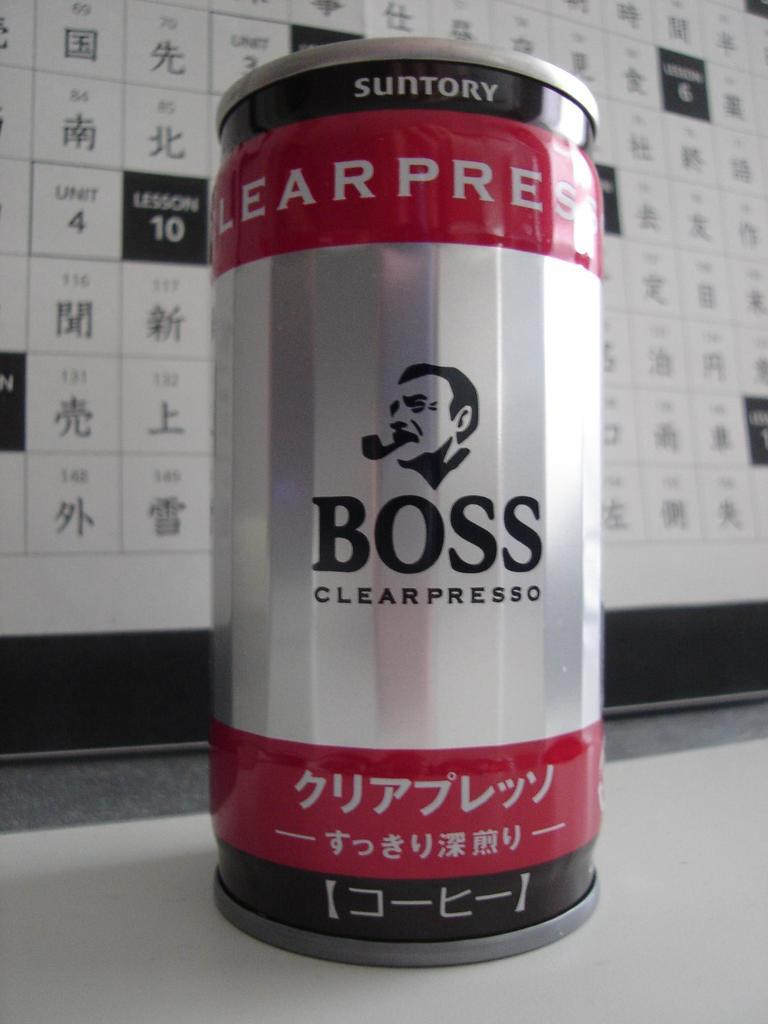<image>
Provide a brief description of the given image. A can of Boss Clearpresso sits on a table. 